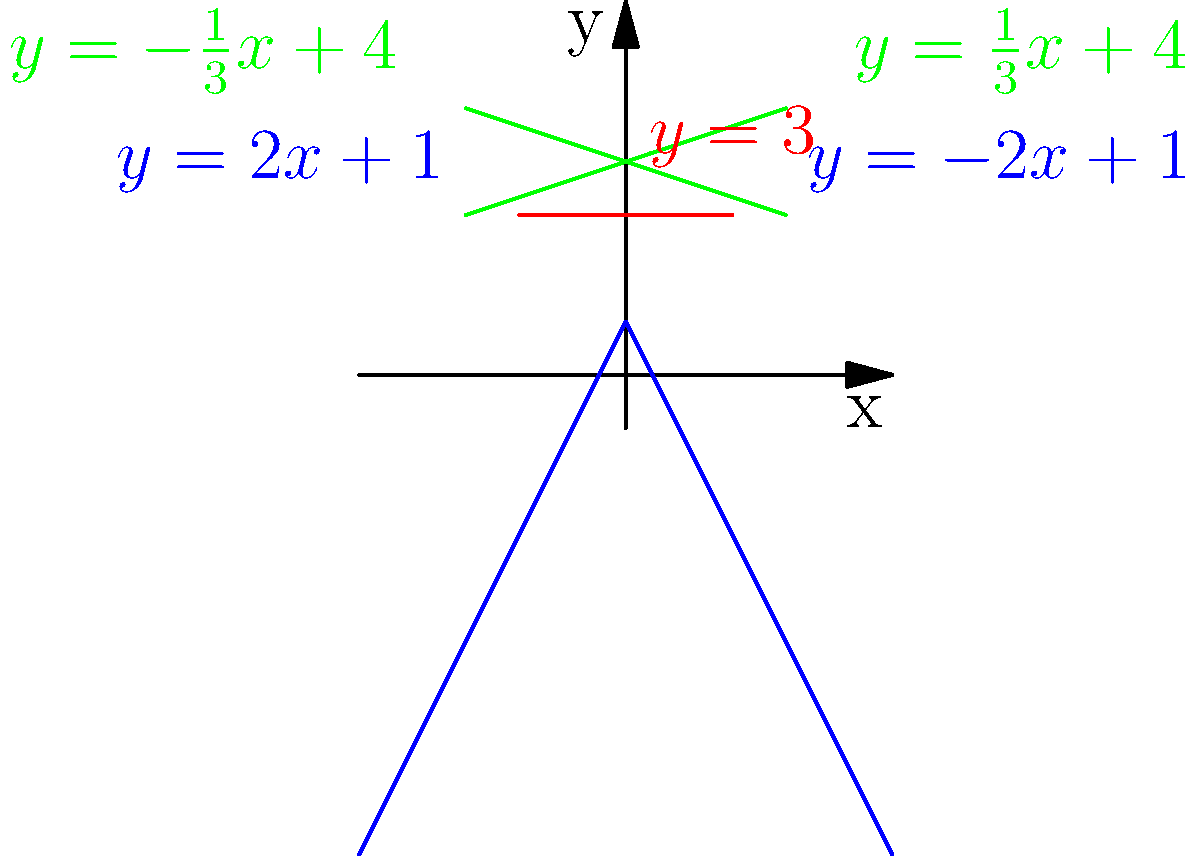In this coordinate system, we see a simple house shape formed by linear equations. Which equation represents the roof of the house, and what is its slope? To answer this question, let's follow these steps:

1. Identify the house shape in the graph:
   - The base is represented by the horizontal red line (y = 3)
   - The walls are the blue lines sloping up from the base
   - The roof is formed by the two green lines meeting at a point

2. The roof lines are represented by the equations:
   $y = -\frac{1}{3}x + 4$ (left side of the roof)
   $y = \frac{1}{3}x + 4$ (right side of the roof)

3. To find the slope of these lines, we can look at the coefficient of x in each equation:
   - For $y = -\frac{1}{3}x + 4$, the slope is $-\frac{1}{3}$
   - For $y = \frac{1}{3}x + 4$, the slope is $\frac{1}{3}$

4. The absolute value of the slope is $\frac{1}{3}$ for both lines, which represents the steepness of the roof.

Therefore, the equations representing the roof of the house are $y = -\frac{1}{3}x + 4$ and $y = \frac{1}{3}x + 4$, and the slope (in absolute terms) is $\frac{1}{3}$.
Answer: $y = \pm\frac{1}{3}x + 4$; slope = $\frac{1}{3}$ 